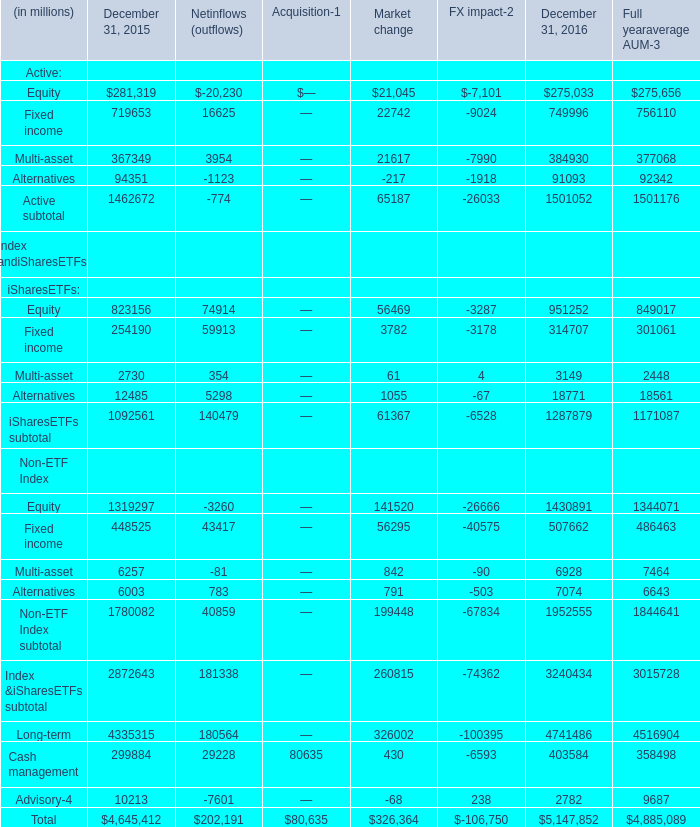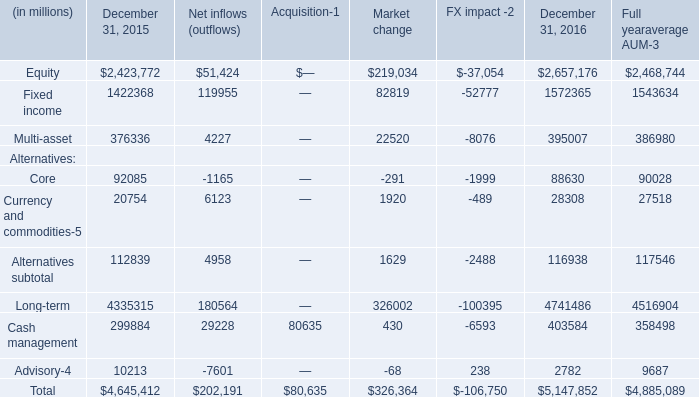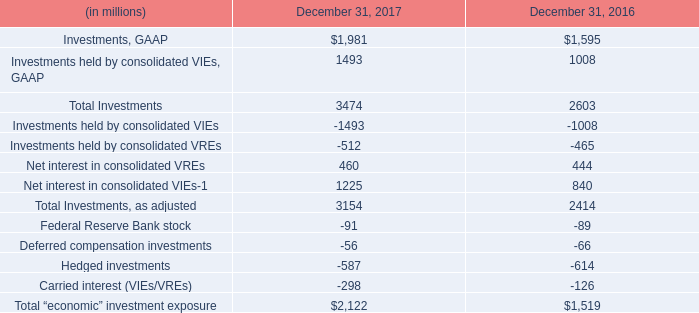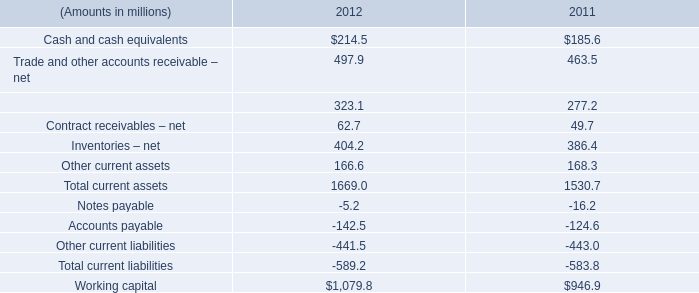What's the average of Active: Fixed income in 2016? (in million) 
Computations: (((16625 + 22742) - 9024) / 4)
Answer: 7585.75. 